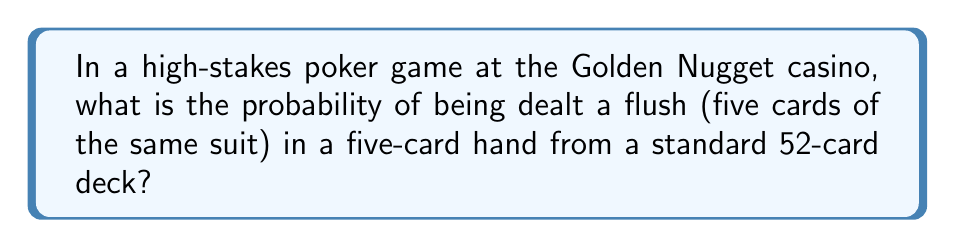Show me your answer to this math problem. Let's approach this step-by-step:

1) First, we need to calculate the total number of possible 5-card hands. This is given by the combination formula:

   $$\binom{52}{5} = \frac{52!}{5!(52-5)!} = 2,598,960$$

2) Now, let's calculate the number of ways to get a flush:
   
   a) Choose one of the 4 suits: $\binom{4}{1} = 4$
   
   b) For each suit, choose 5 cards out of 13: $\binom{13}{5} = 1,287$

3) Multiply these together to get the total number of flush hands:

   $$4 \times 1,287 = 5,148$$

4) The probability is then the number of favorable outcomes divided by the total number of possible outcomes:

   $$P(\text{Flush}) = \frac{5,148}{2,598,960} = \frac{1,287}{649,740} \approx 0.00198$$

5) This can be expressed as a percentage:

   $$0.00198 \times 100\% \approx 0.198\%$$
Answer: $\frac{1,287}{649,740}$ or approximately 0.198% 